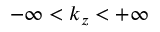<formula> <loc_0><loc_0><loc_500><loc_500>- \infty < k _ { z } < + \infty</formula> 